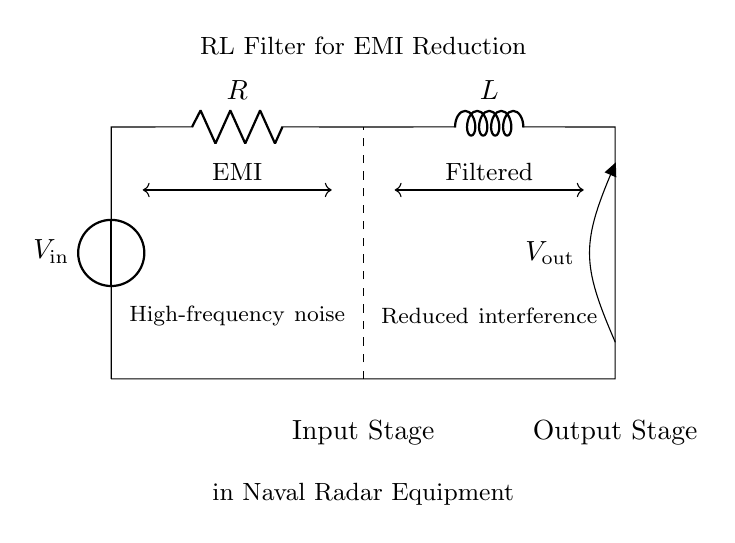What is the input voltage represented in the diagram? The input voltage \( V_{\text{in}} \) is labeled as such in the circuit diagram near the voltage source.
Answer: \( V_{\text{in}} \) What type of components are in the circuit? The circuit consists of a resistor and an inductor, which are the two main components highlighted in the diagram.
Answer: Resistor and Inductor What does the dashed line represent? The dashed line in the circuit connects the input and output stages, highlighting that they are part of the same signal path in the filter design.
Answer: Connection between stages What type of filter is indicated in this circuit? The circuit is specifically labeled as an RL filter, which is used for reducing electromagnetic interference as shown in the annotations.
Answer: RL filter What is the purpose of this RL circuit in the context given? The RL filter is designed to reduce high-frequency noise, making it especially important for electromagnetic interference reduction in naval radar equipment.
Answer: Reduce electromagnetic interference What happens to high-frequency noise in this circuit? High-frequency noise is significantly attenuated or filtered out as the signal passes through the RL circuit, resulting in reduced interference at the output.
Answer: Attenuation of high-frequency noise What is the output voltage labeled in the diagram? The output voltage is labeled \( V_{\text{out}} \), indicating the voltage after the filtering process has occurred in this RL circuit.
Answer: \( V_{\text{out}} \) 